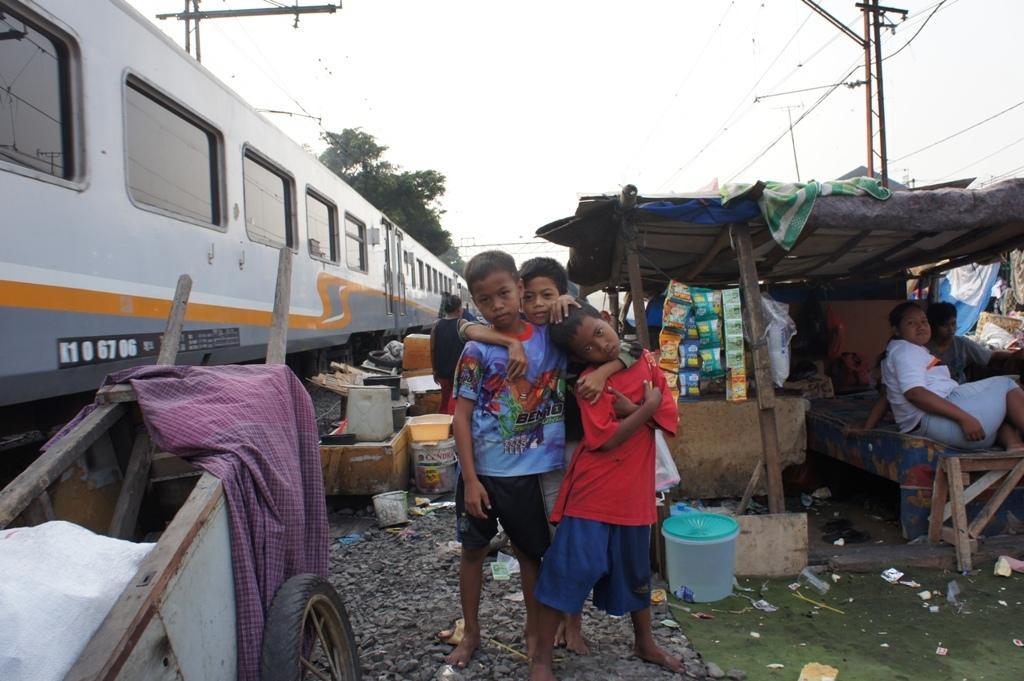Please provide a concise description of this image. In this picture we can see there are three kids standing on the stone path. On the left side of the kids there is a cart, train and trees. On the right side of the kids there are people sitting. Behind the kids there are electric poles with cables and a sky. 